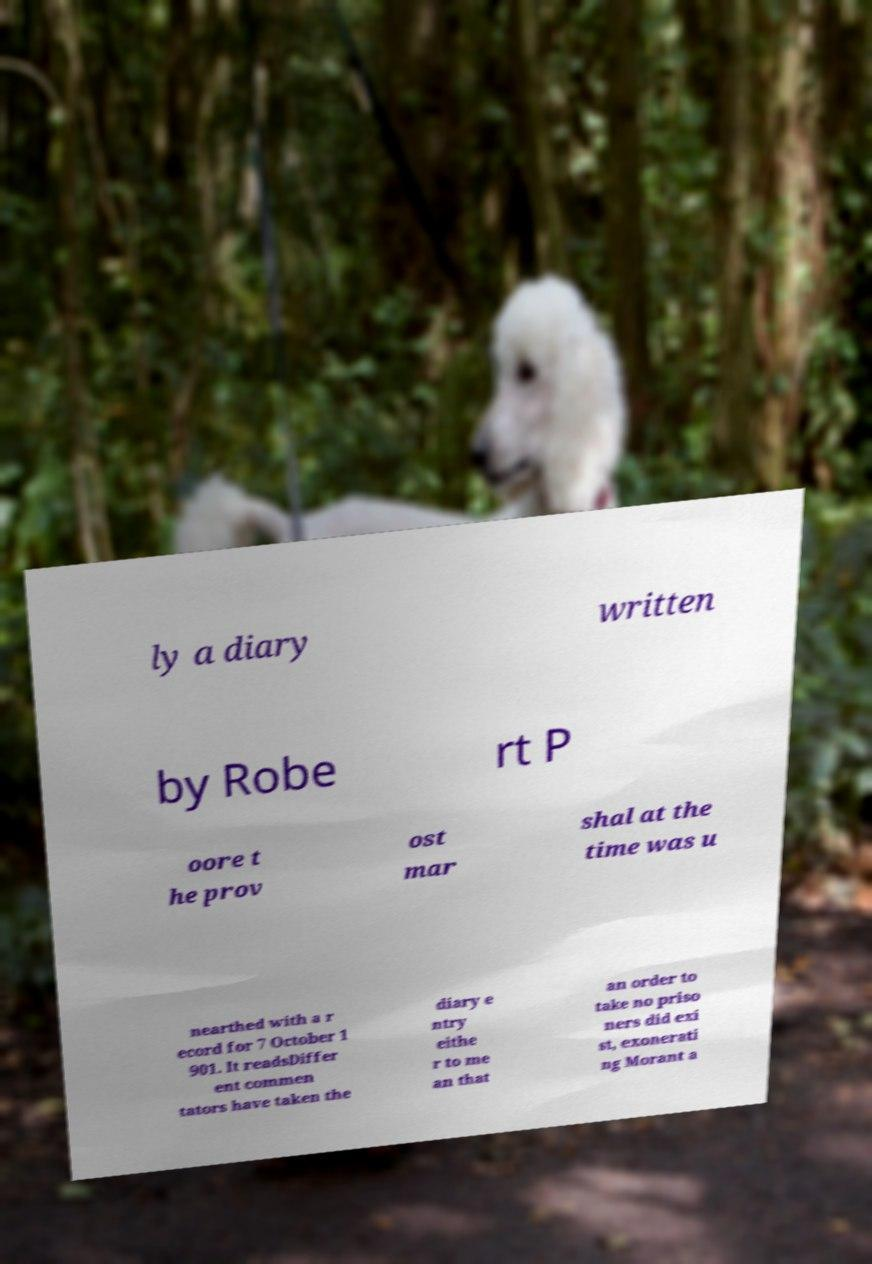There's text embedded in this image that I need extracted. Can you transcribe it verbatim? ly a diary written by Robe rt P oore t he prov ost mar shal at the time was u nearthed with a r ecord for 7 October 1 901. It readsDiffer ent commen tators have taken the diary e ntry eithe r to me an that an order to take no priso ners did exi st, exonerati ng Morant a 